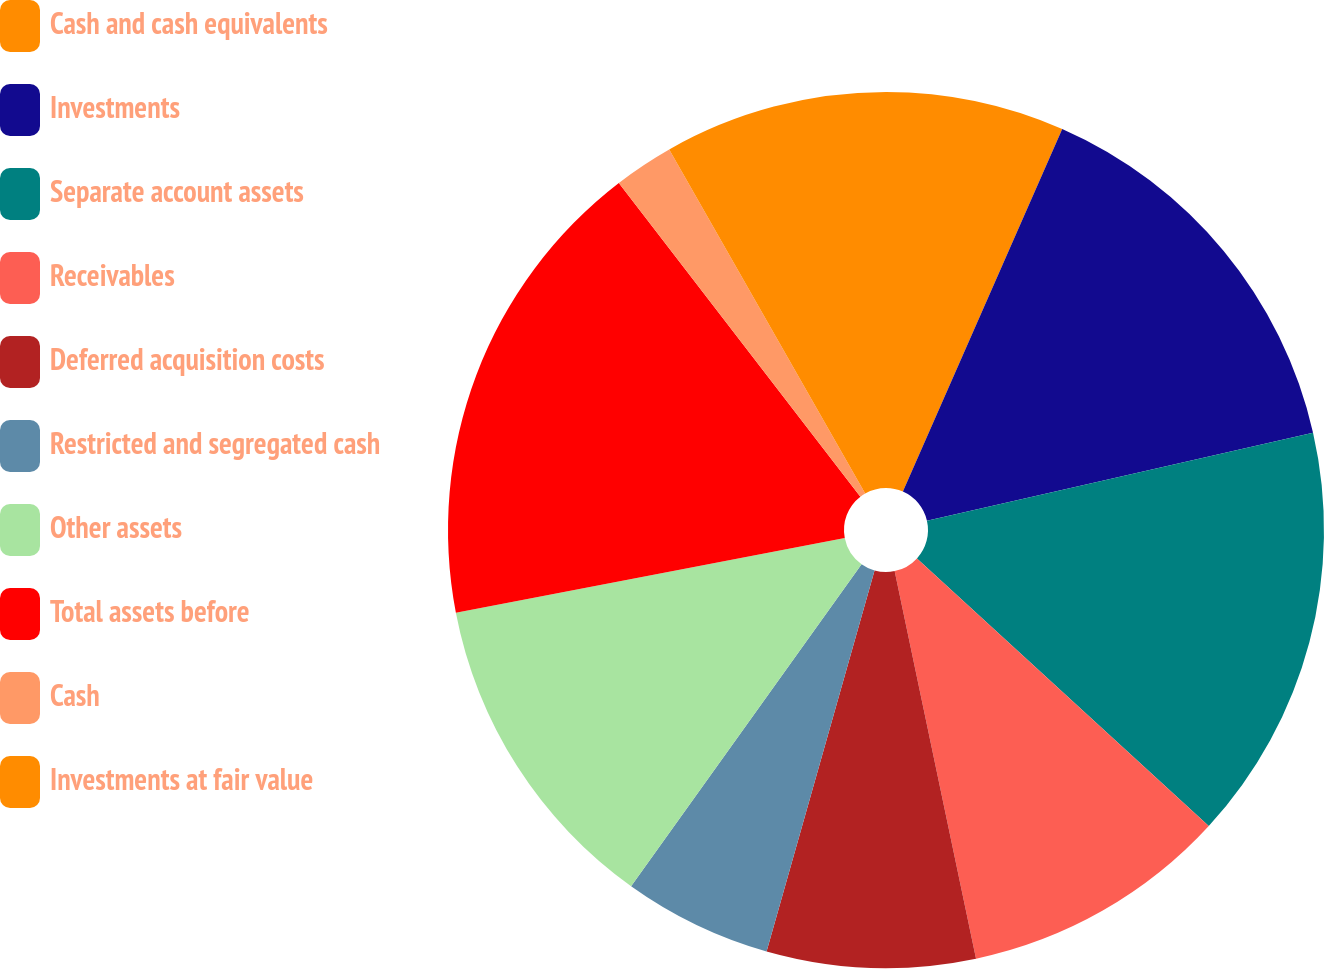Convert chart to OTSL. <chart><loc_0><loc_0><loc_500><loc_500><pie_chart><fcel>Cash and cash equivalents<fcel>Investments<fcel>Separate account assets<fcel>Receivables<fcel>Deferred acquisition costs<fcel>Restricted and segregated cash<fcel>Other assets<fcel>Total assets before<fcel>Cash<fcel>Investments at fair value<nl><fcel>6.59%<fcel>14.84%<fcel>15.38%<fcel>9.89%<fcel>7.69%<fcel>5.49%<fcel>12.09%<fcel>17.58%<fcel>2.2%<fcel>8.24%<nl></chart> 